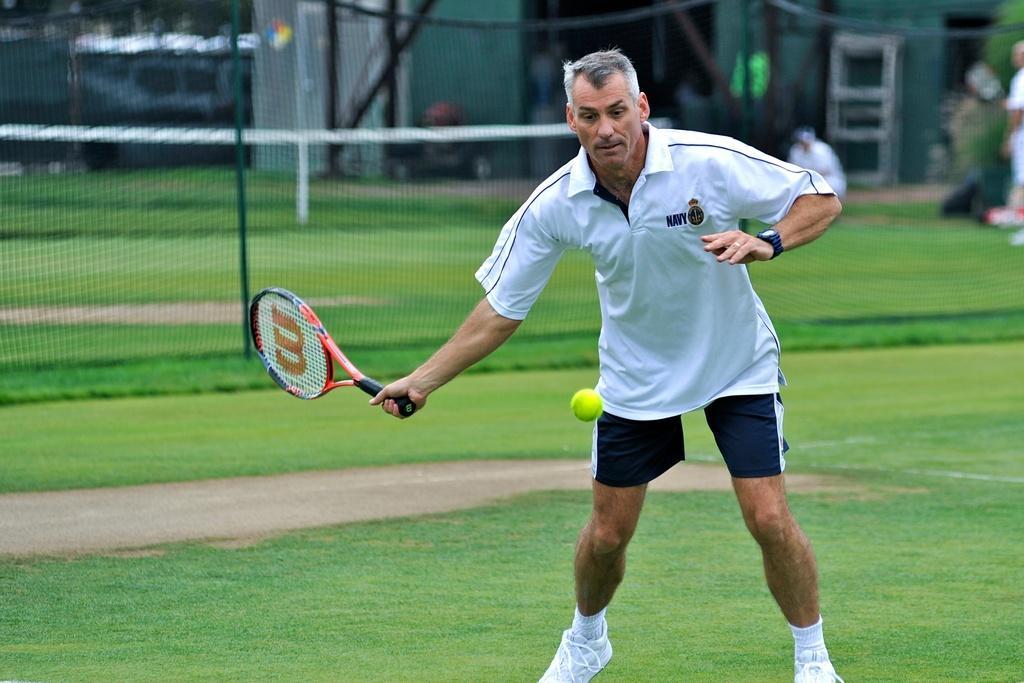Can you describe this image briefly? As we can see in the image there is a grass, fence, a man holding shuttle bat and there is a yellow color boll. 